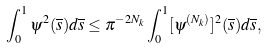Convert formula to latex. <formula><loc_0><loc_0><loc_500><loc_500>\int _ { 0 } ^ { 1 } \psi ^ { 2 } ( \overline { s } ) d \overline { s } \leq \pi ^ { - 2 N _ { k } } \int _ { 0 } ^ { 1 } [ \psi ^ { ( N _ { k } ) } ] ^ { 2 } ( \overline { s } ) d \overline { s } ,</formula> 